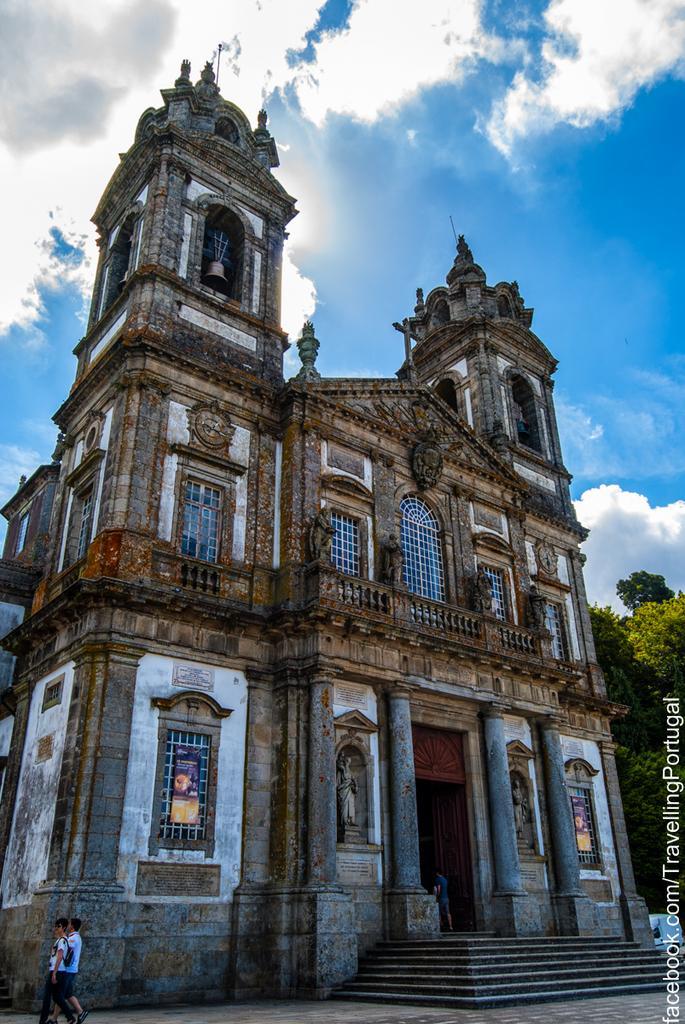How would you summarize this image in a sentence or two? In this picture there are people and we can see building, boards on windows, statues, steps and trees. In the background of the image we can see the sky with clouds. In the bottom right side of the image we can see text. 